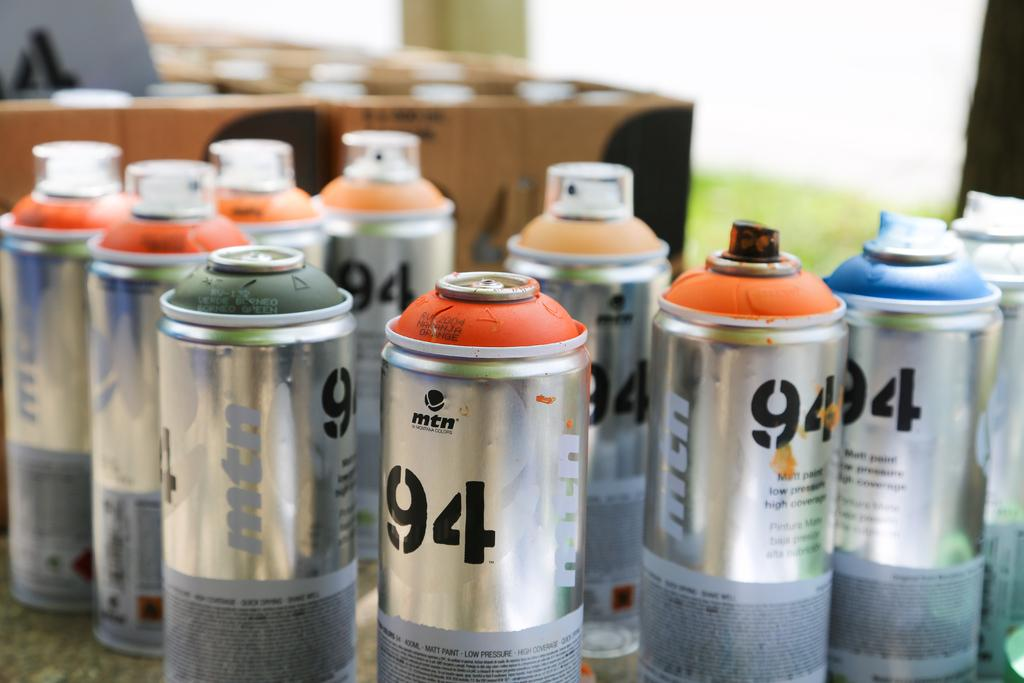<image>
Describe the image concisely. several bottles of spray paint with the number 94 on the sides 